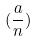<formula> <loc_0><loc_0><loc_500><loc_500>( \frac { a } { n } )</formula> 